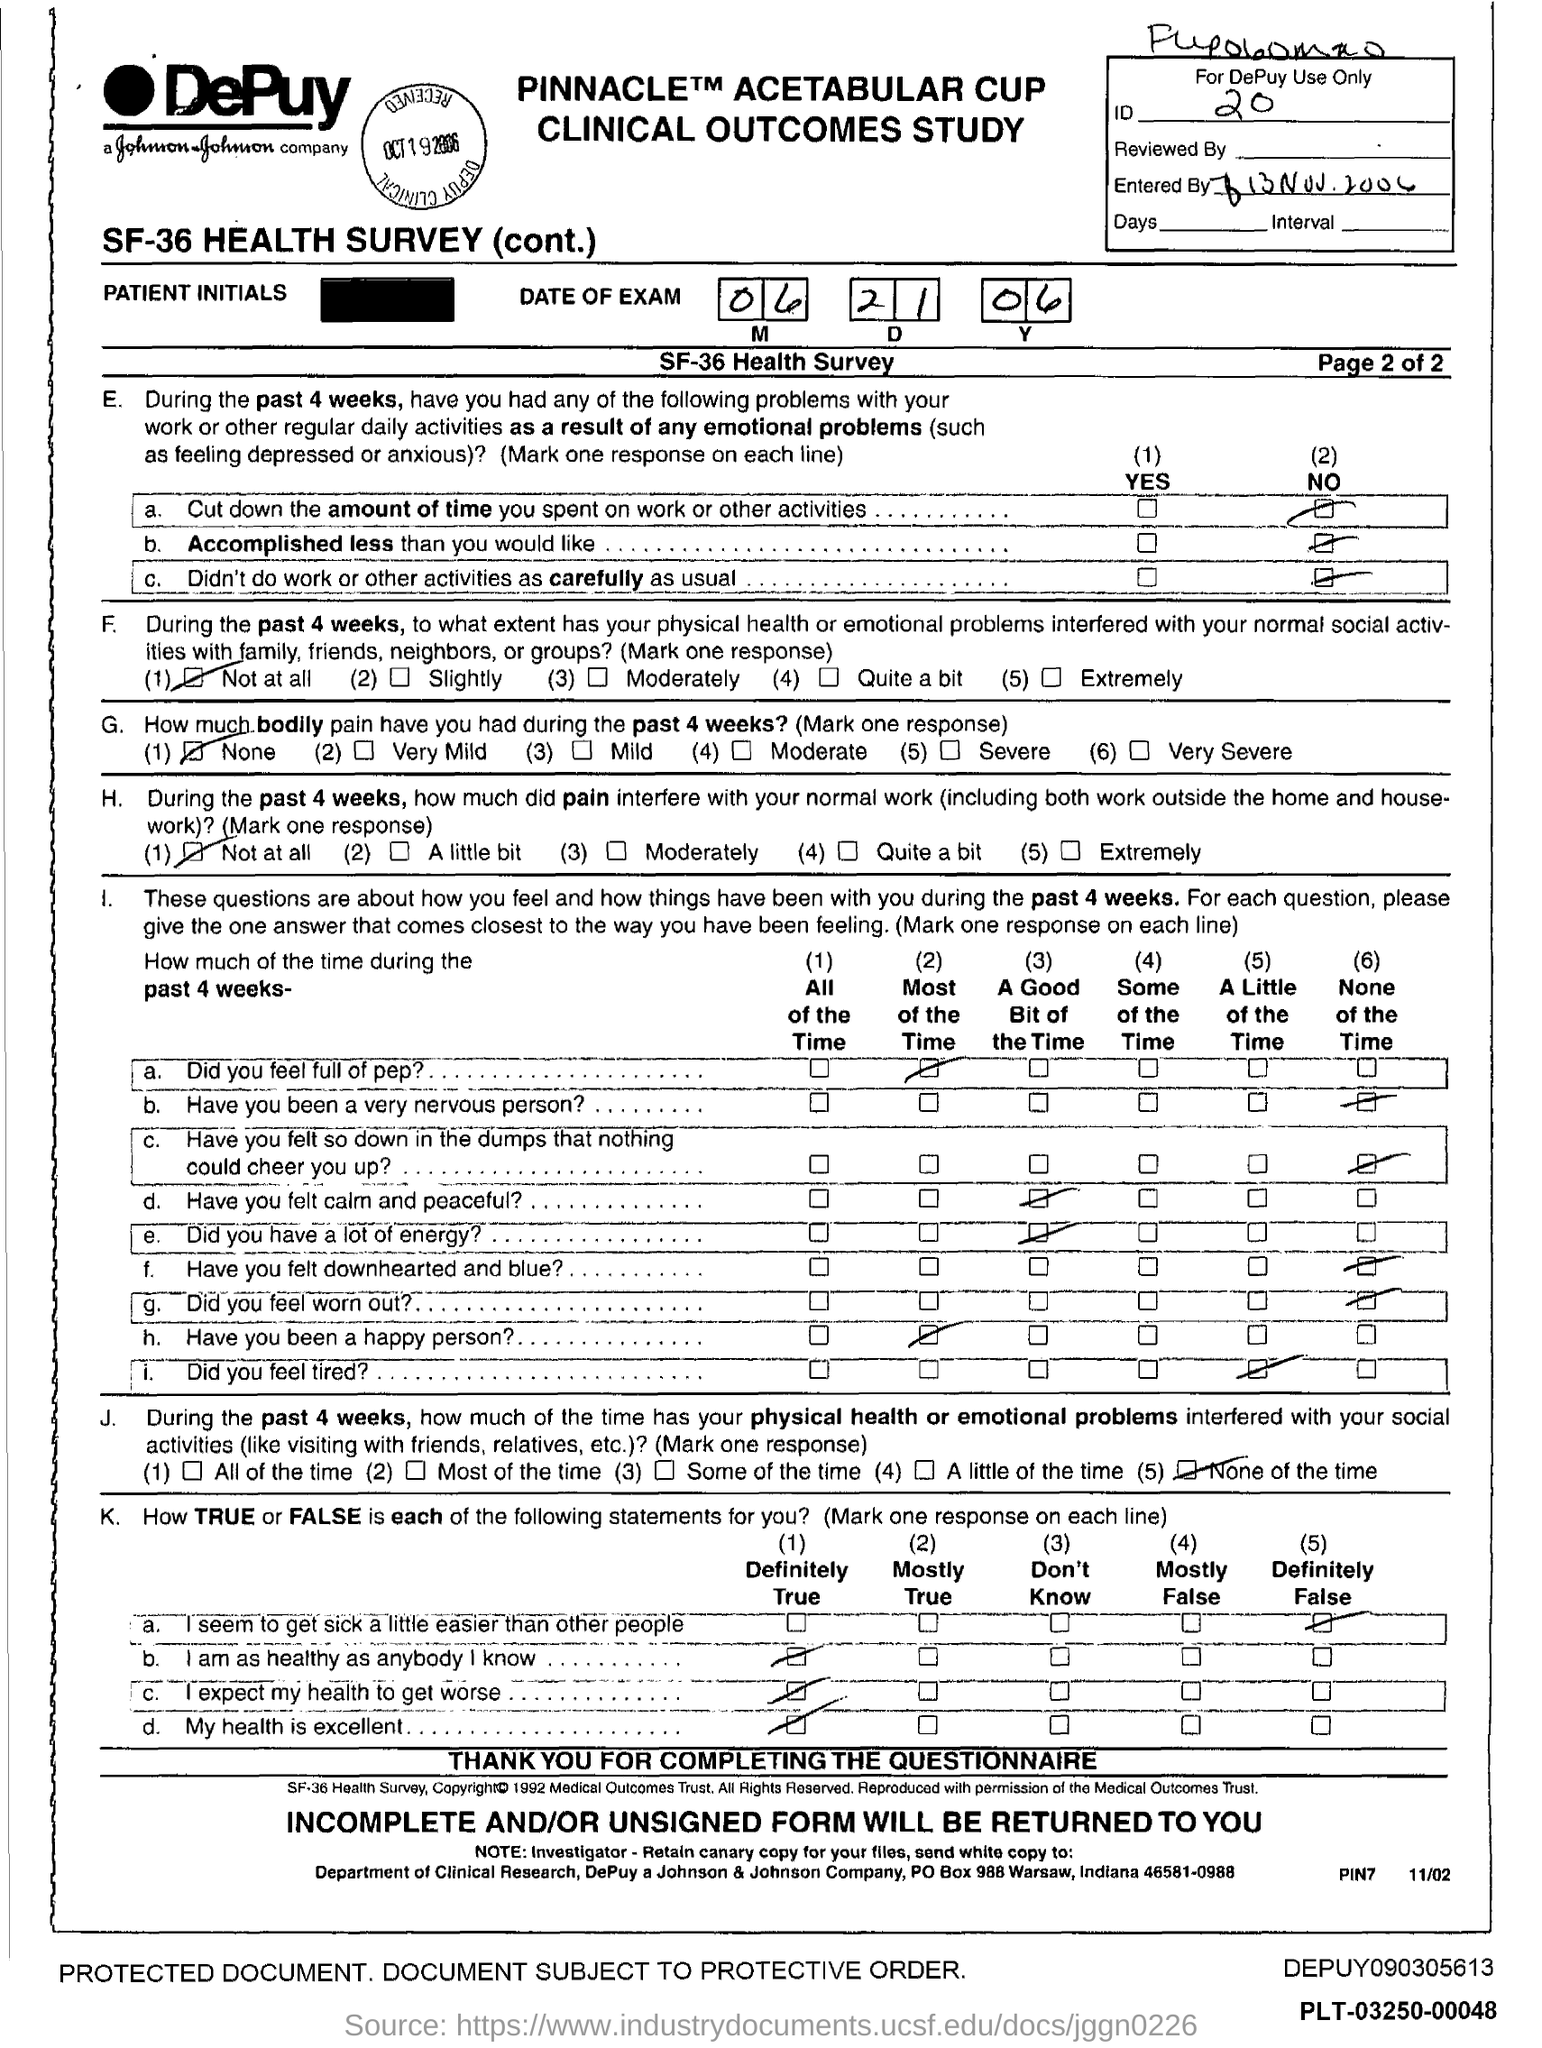Give some essential details in this illustration. What is the ID number?" the man asked, his voice full of urgency. "It's 20...," he continued, his voice trailing off as he stared at the glowing screen. Johnson & Johnson is headquartered in the state of Indiana. The PO box number for Johnson & Johnson Company is 988. 